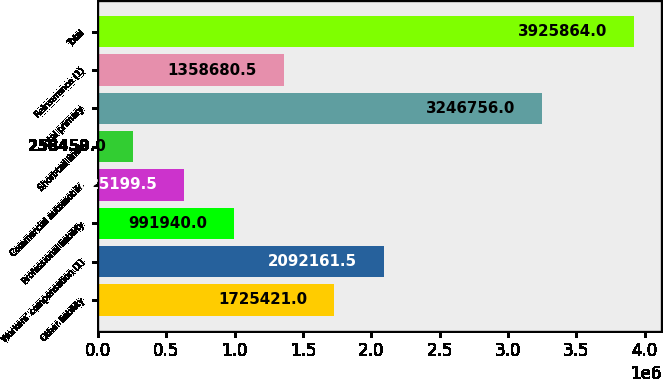<chart> <loc_0><loc_0><loc_500><loc_500><bar_chart><fcel>Other liability<fcel>Workers' compensation (1)<fcel>Professional liability<fcel>Commercial automobile<fcel>Short-tail lines<fcel>Total primary<fcel>Reinsurance (1)<fcel>Total<nl><fcel>1.72542e+06<fcel>2.09216e+06<fcel>991940<fcel>625200<fcel>258459<fcel>3.24676e+06<fcel>1.35868e+06<fcel>3.92586e+06<nl></chart> 